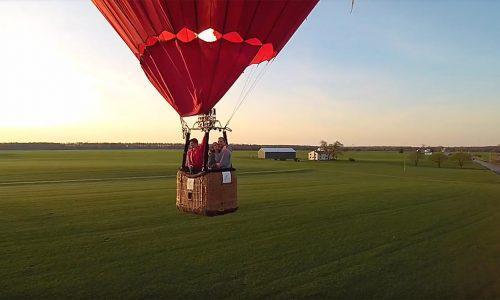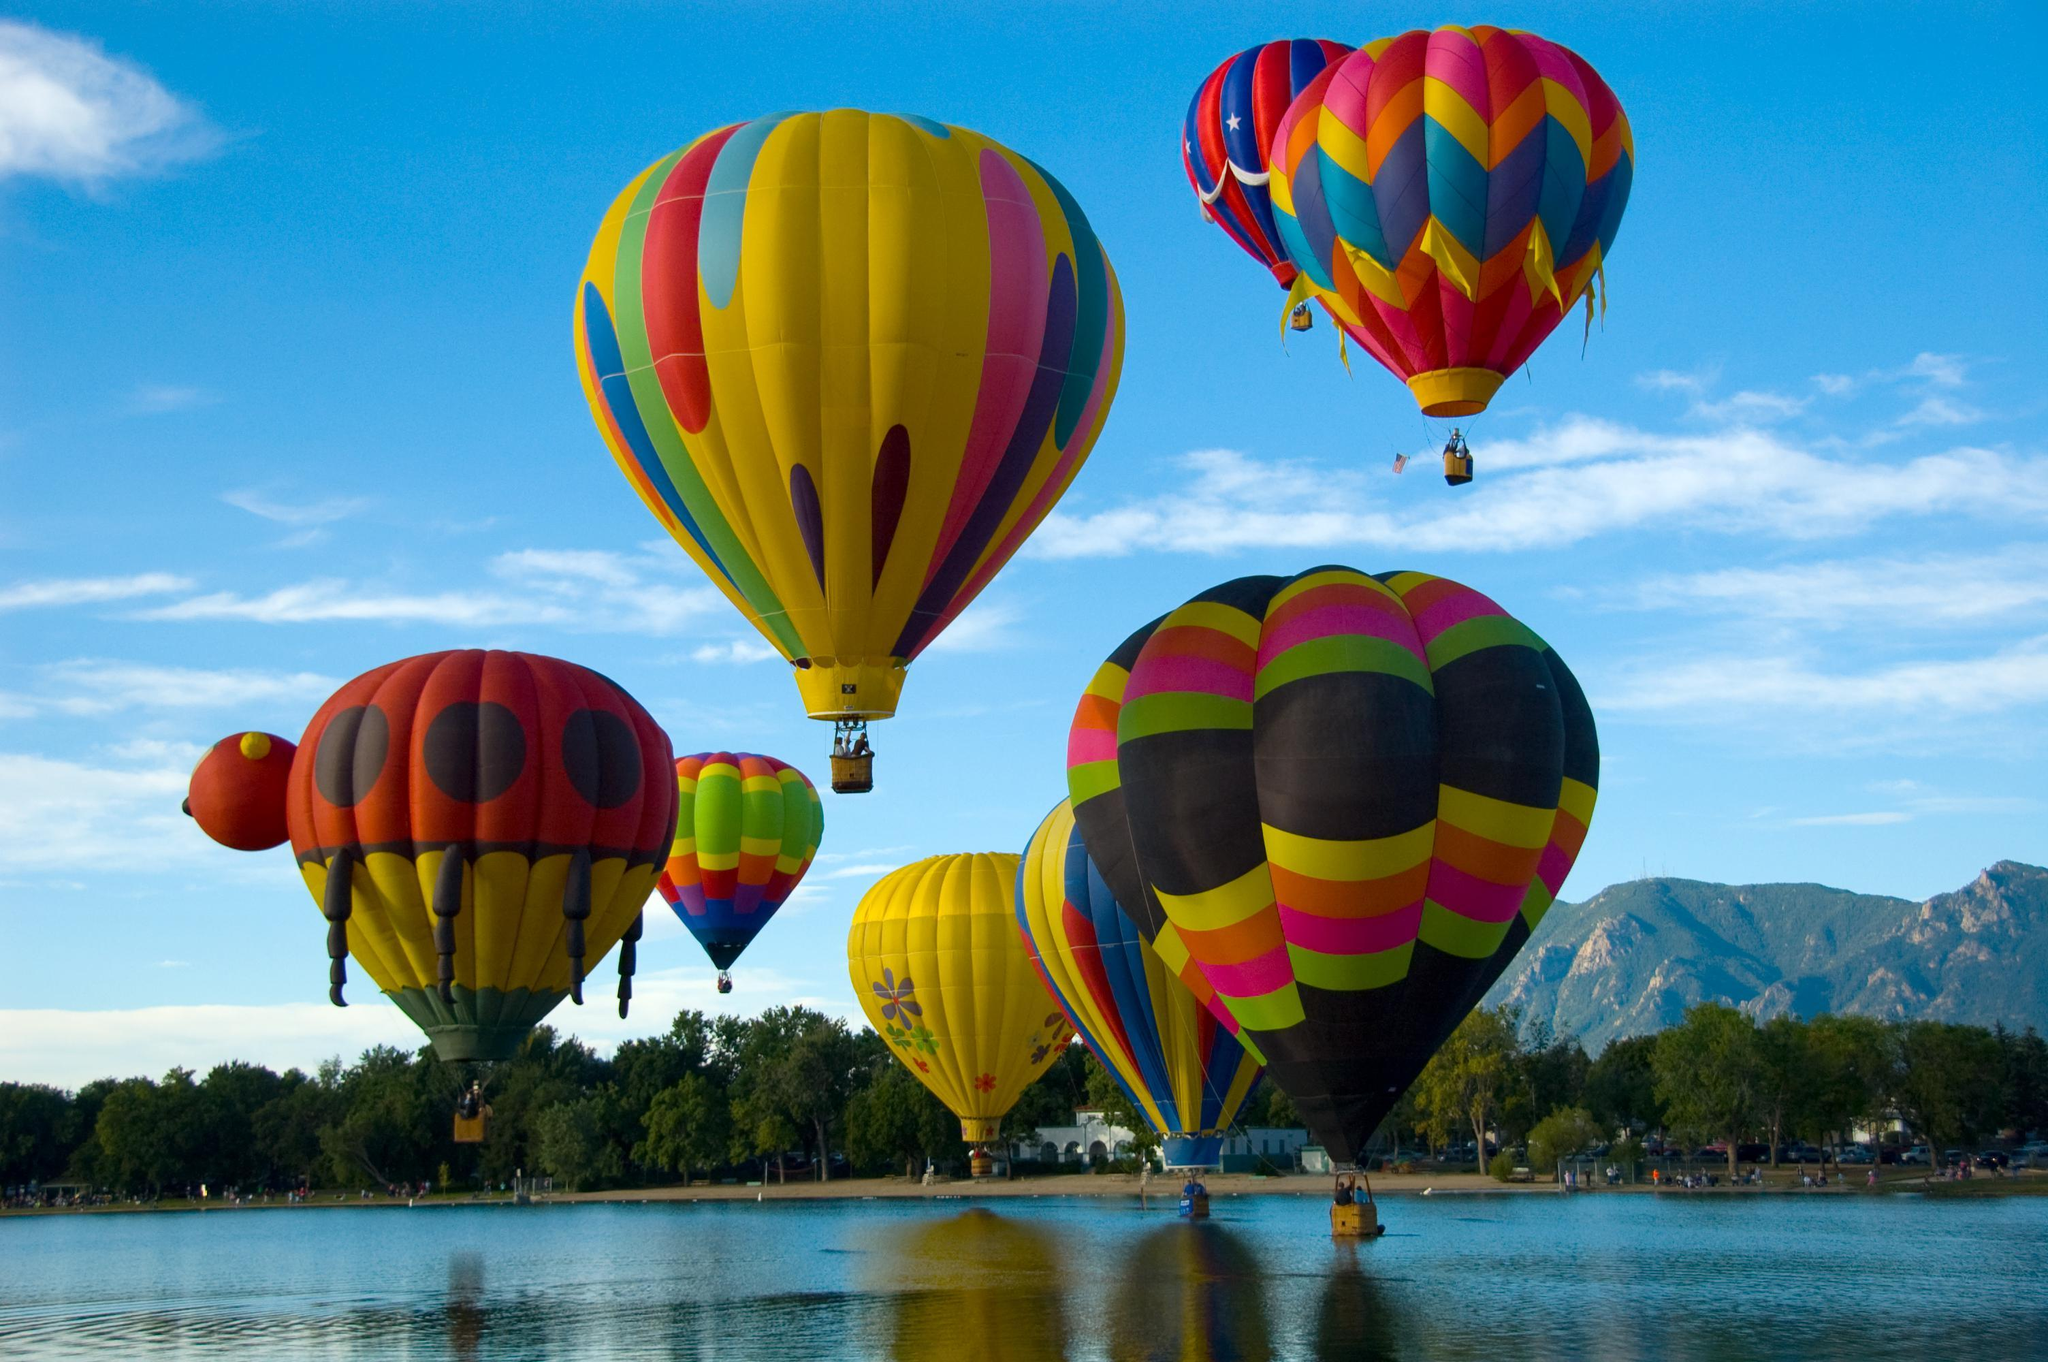The first image is the image on the left, the second image is the image on the right. Analyze the images presented: Is the assertion "There are more than 5 balloons in one of the images." valid? Answer yes or no. Yes. 